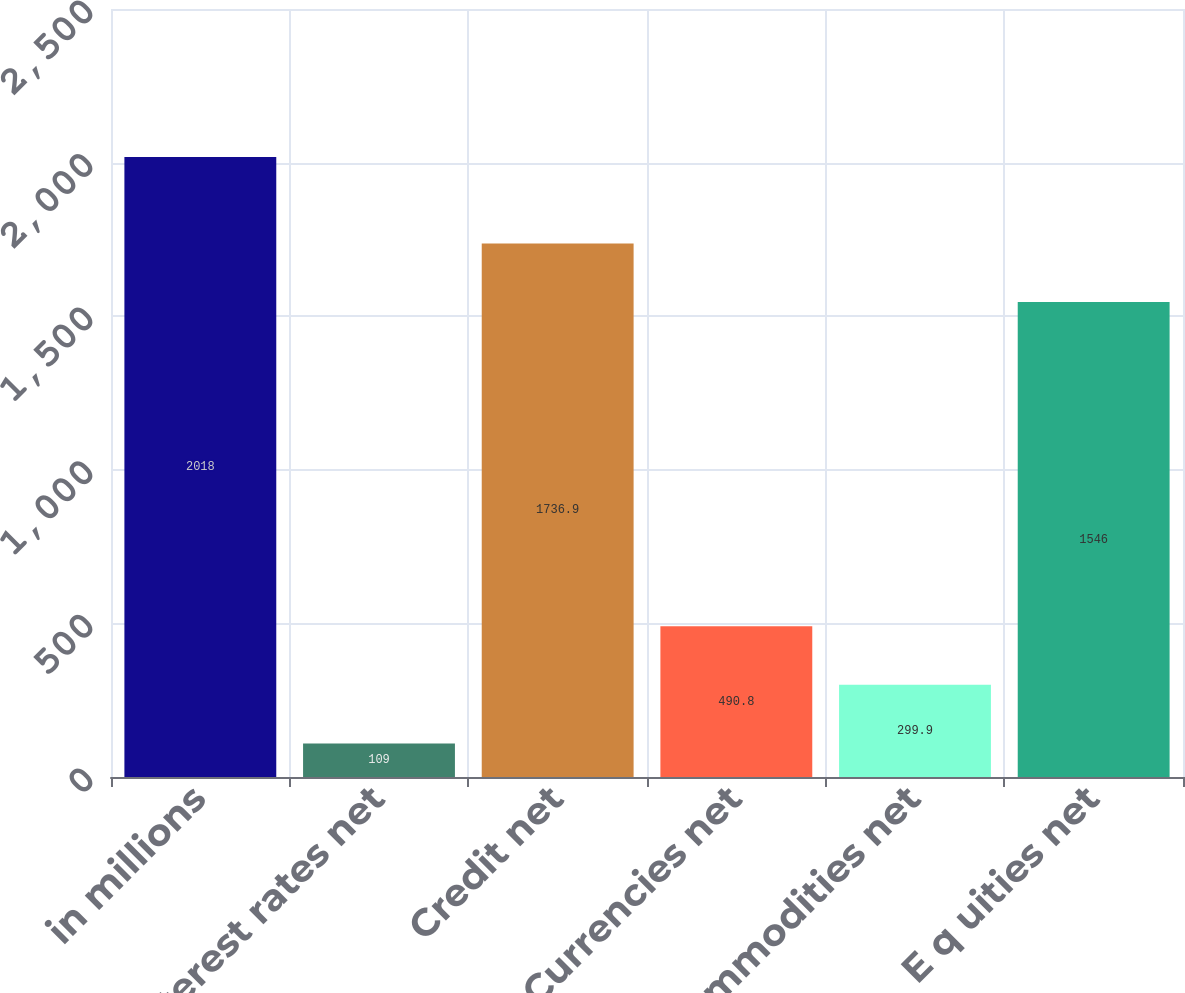Convert chart. <chart><loc_0><loc_0><loc_500><loc_500><bar_chart><fcel>in millions<fcel>Interest rates net<fcel>Credit net<fcel>Currencies net<fcel>Commodities net<fcel>E q uities net<nl><fcel>2018<fcel>109<fcel>1736.9<fcel>490.8<fcel>299.9<fcel>1546<nl></chart> 